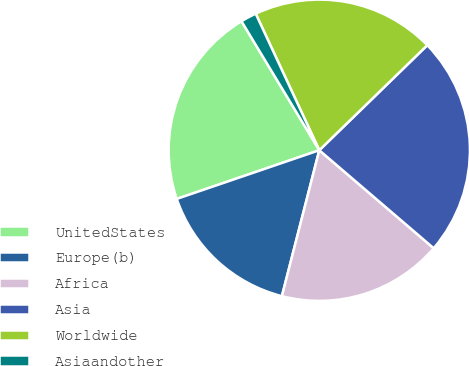Convert chart. <chart><loc_0><loc_0><loc_500><loc_500><pie_chart><fcel>UnitedStates<fcel>Europe(b)<fcel>Africa<fcel>Asia<fcel>Worldwide<fcel>Asiaandother<nl><fcel>21.6%<fcel>15.77%<fcel>17.72%<fcel>23.55%<fcel>19.66%<fcel>1.7%<nl></chart> 